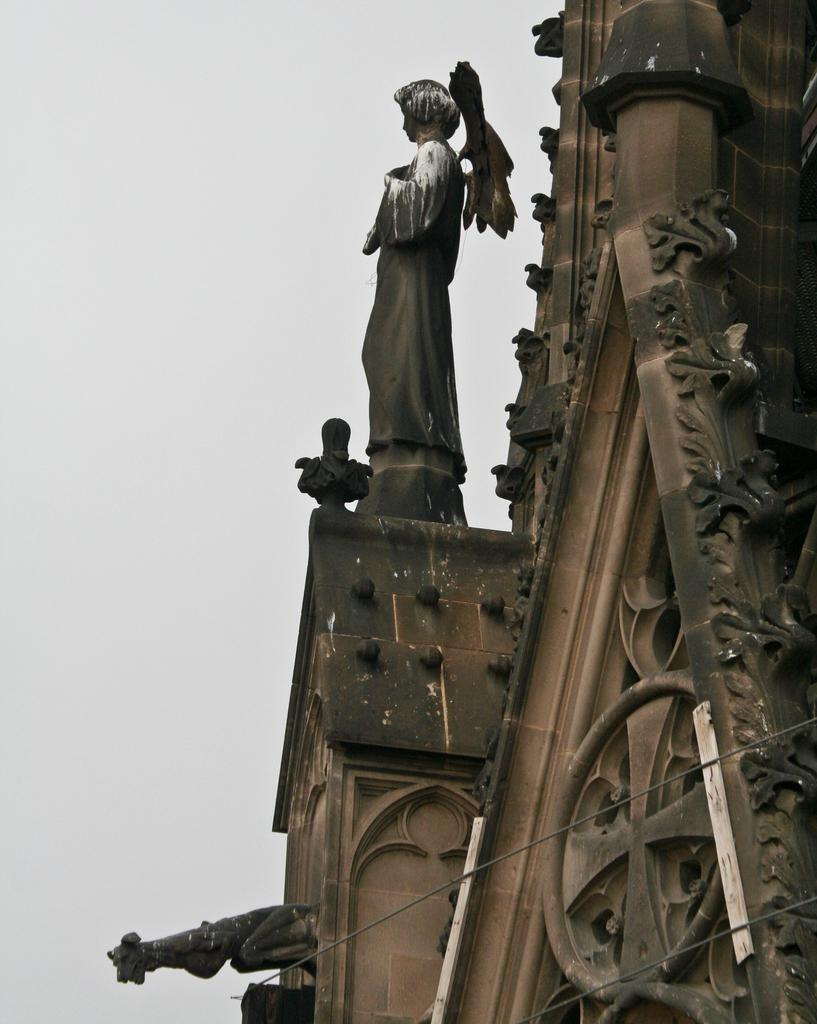What structure is located on the left side of the image? There is a building on the left side of the image. What is on the building in the image? There is a sculpture on the building. What is the condition of the sky in the image? The sky is cloudy in the image. What type of worm can be seen crawling on the sculpture in the image? There is no worm present in the image; it features a building with a sculpture and a cloudy sky. How is the jam being used in the image? There is no jam present in the image. 